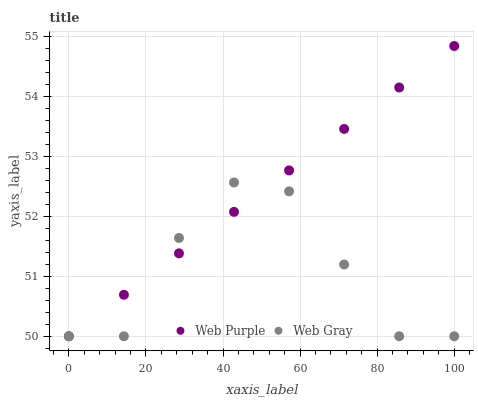Does Web Gray have the minimum area under the curve?
Answer yes or no. Yes. Does Web Purple have the maximum area under the curve?
Answer yes or no. Yes. Does Web Gray have the maximum area under the curve?
Answer yes or no. No. Is Web Purple the smoothest?
Answer yes or no. Yes. Is Web Gray the roughest?
Answer yes or no. Yes. Is Web Gray the smoothest?
Answer yes or no. No. Does Web Purple have the lowest value?
Answer yes or no. Yes. Does Web Purple have the highest value?
Answer yes or no. Yes. Does Web Gray have the highest value?
Answer yes or no. No. Does Web Purple intersect Web Gray?
Answer yes or no. Yes. Is Web Purple less than Web Gray?
Answer yes or no. No. Is Web Purple greater than Web Gray?
Answer yes or no. No. 